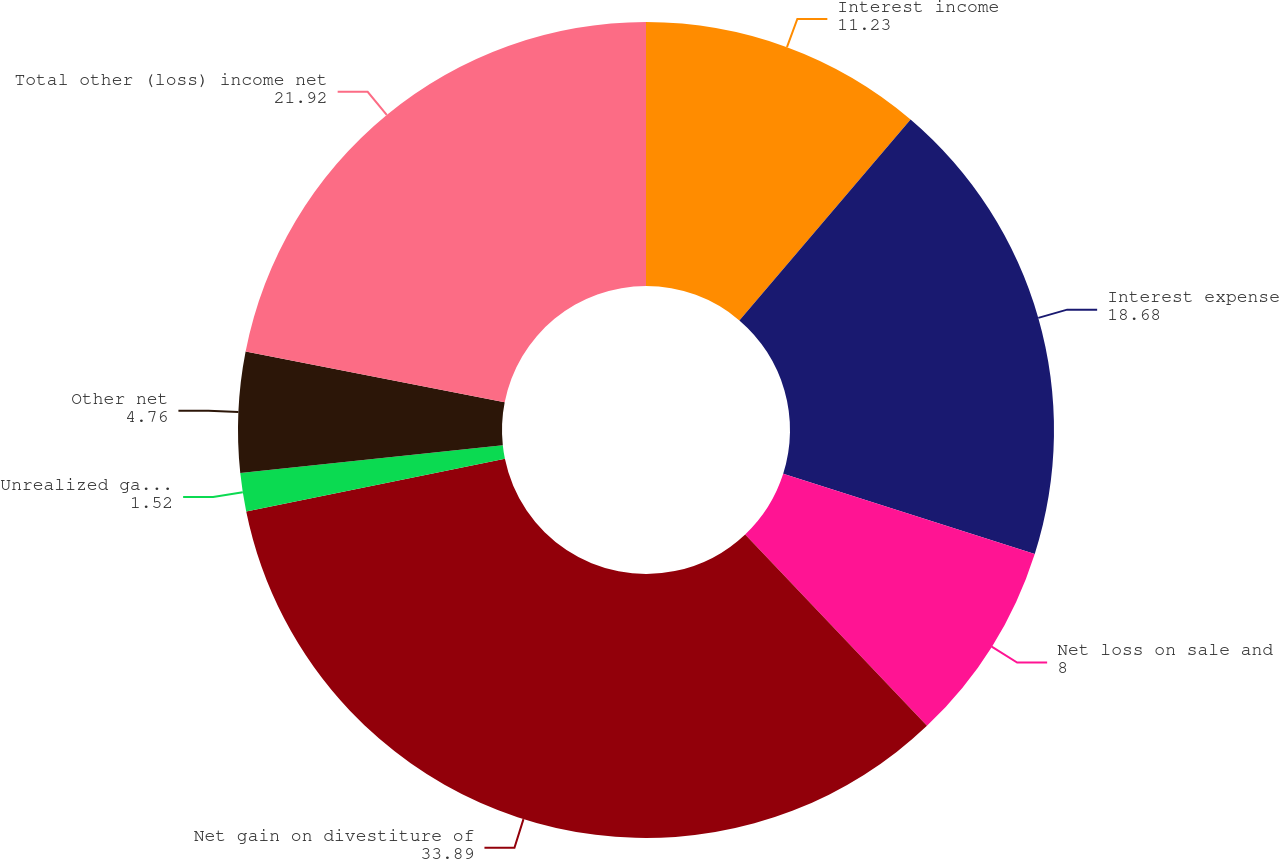<chart> <loc_0><loc_0><loc_500><loc_500><pie_chart><fcel>Interest income<fcel>Interest expense<fcel>Net loss on sale and<fcel>Net gain on divestiture of<fcel>Unrealized gain (loss) on<fcel>Other net<fcel>Total other (loss) income net<nl><fcel>11.23%<fcel>18.68%<fcel>8.0%<fcel>33.89%<fcel>1.52%<fcel>4.76%<fcel>21.92%<nl></chart> 